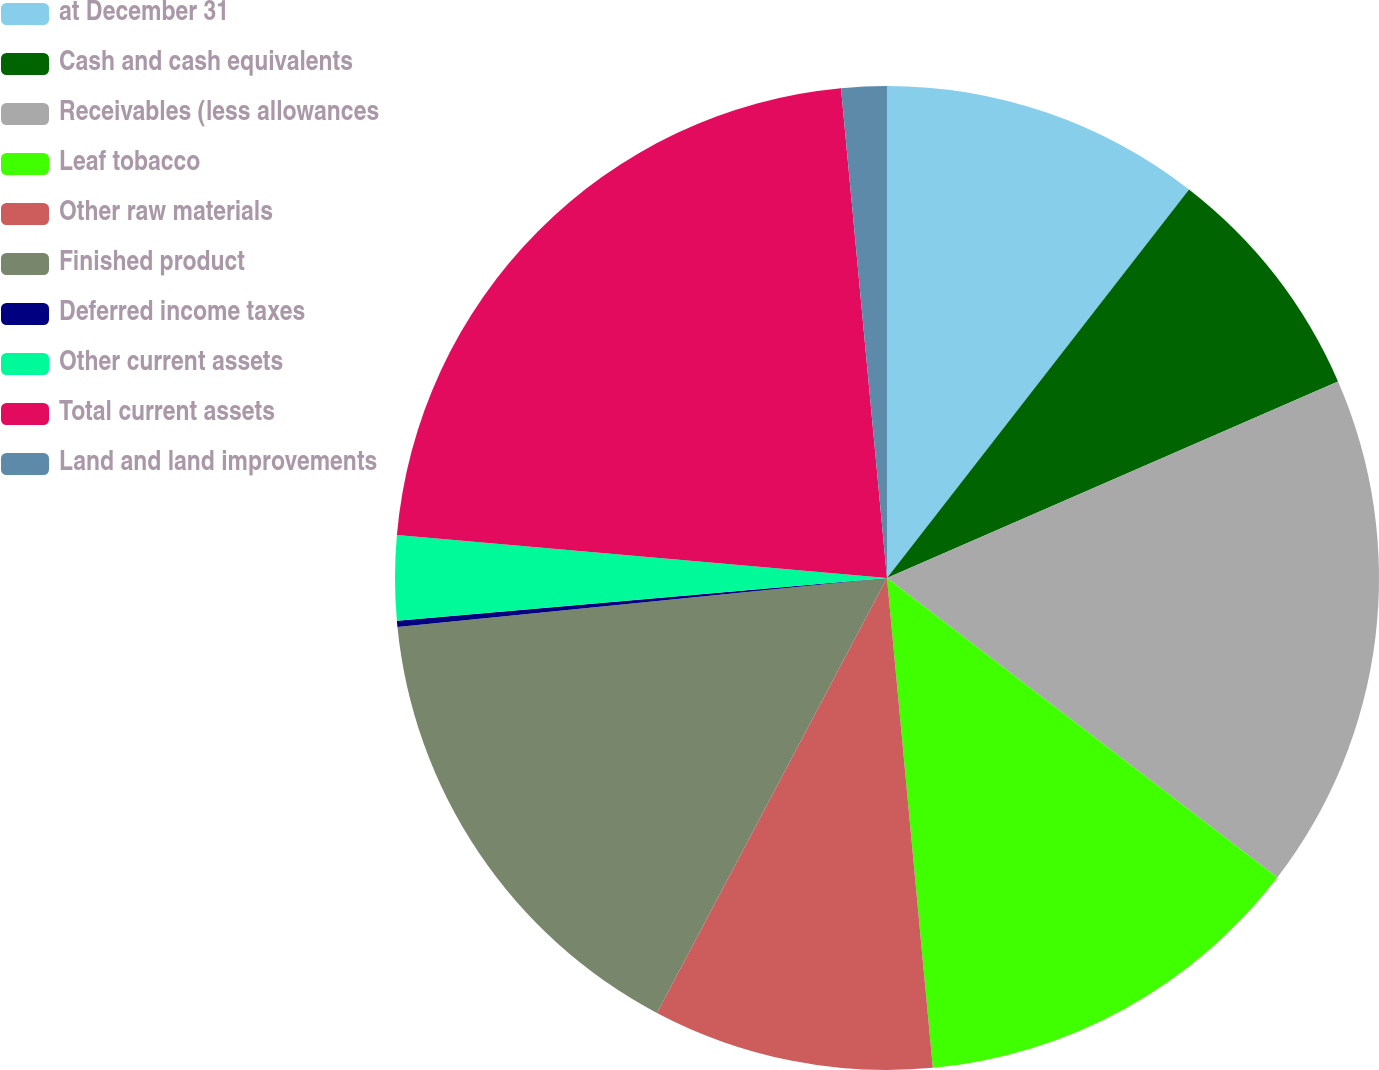<chart> <loc_0><loc_0><loc_500><loc_500><pie_chart><fcel>at December 31<fcel>Cash and cash equivalents<fcel>Receivables (less allowances<fcel>Leaf tobacco<fcel>Other raw materials<fcel>Finished product<fcel>Deferred income taxes<fcel>Other current assets<fcel>Total current assets<fcel>Land and land improvements<nl><fcel>10.52%<fcel>7.94%<fcel>16.96%<fcel>13.1%<fcel>9.23%<fcel>15.67%<fcel>0.2%<fcel>2.78%<fcel>22.12%<fcel>1.49%<nl></chart> 